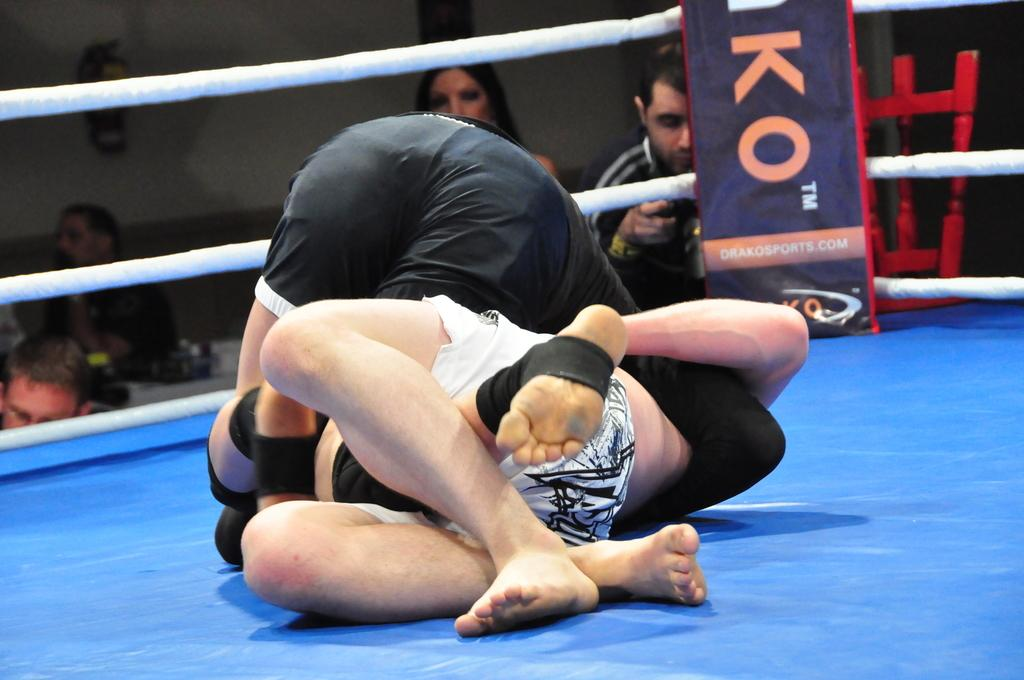<image>
Write a terse but informative summary of the picture. Two wrestlers are in the ring engaged in a match there are spectators and a black flag with orange letters: KO. TM, Drakosports.com 